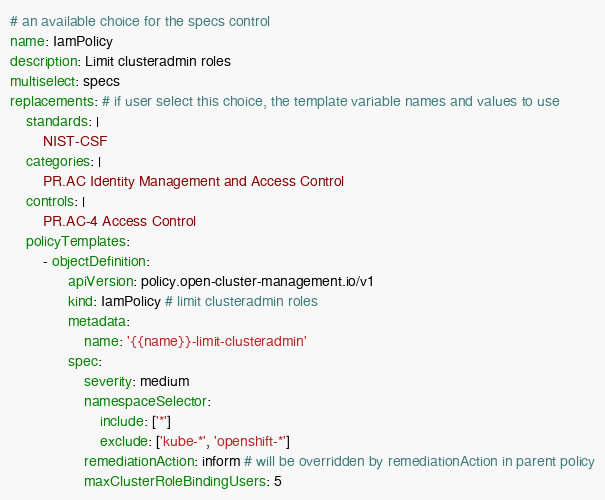Convert code to text. <code><loc_0><loc_0><loc_500><loc_500><_YAML_># an available choice for the specs control
name: IamPolicy
description: Limit clusteradmin roles
multiselect: specs
replacements: # if user select this choice, the template variable names and values to use
    standards: |
        NIST-CSF
    categories: |
        PR.AC Identity Management and Access Control
    controls: |
        PR.AC-4 Access Control
    policyTemplates:
        - objectDefinition:
              apiVersion: policy.open-cluster-management.io/v1
              kind: IamPolicy # limit clusteradmin roles
              metadata:
                  name: '{{name}}-limit-clusteradmin'
              spec:
                  severity: medium
                  namespaceSelector:
                      include: ['*']
                      exclude: ['kube-*', 'openshift-*']
                  remediationAction: inform # will be overridden by remediationAction in parent policy
                  maxClusterRoleBindingUsers: 5
</code> 